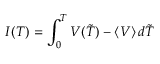<formula> <loc_0><loc_0><loc_500><loc_500>I ( T ) = \int _ { 0 } ^ { T } V ( \tilde { T } ) - \langle V \rangle \, d \tilde { T }</formula> 